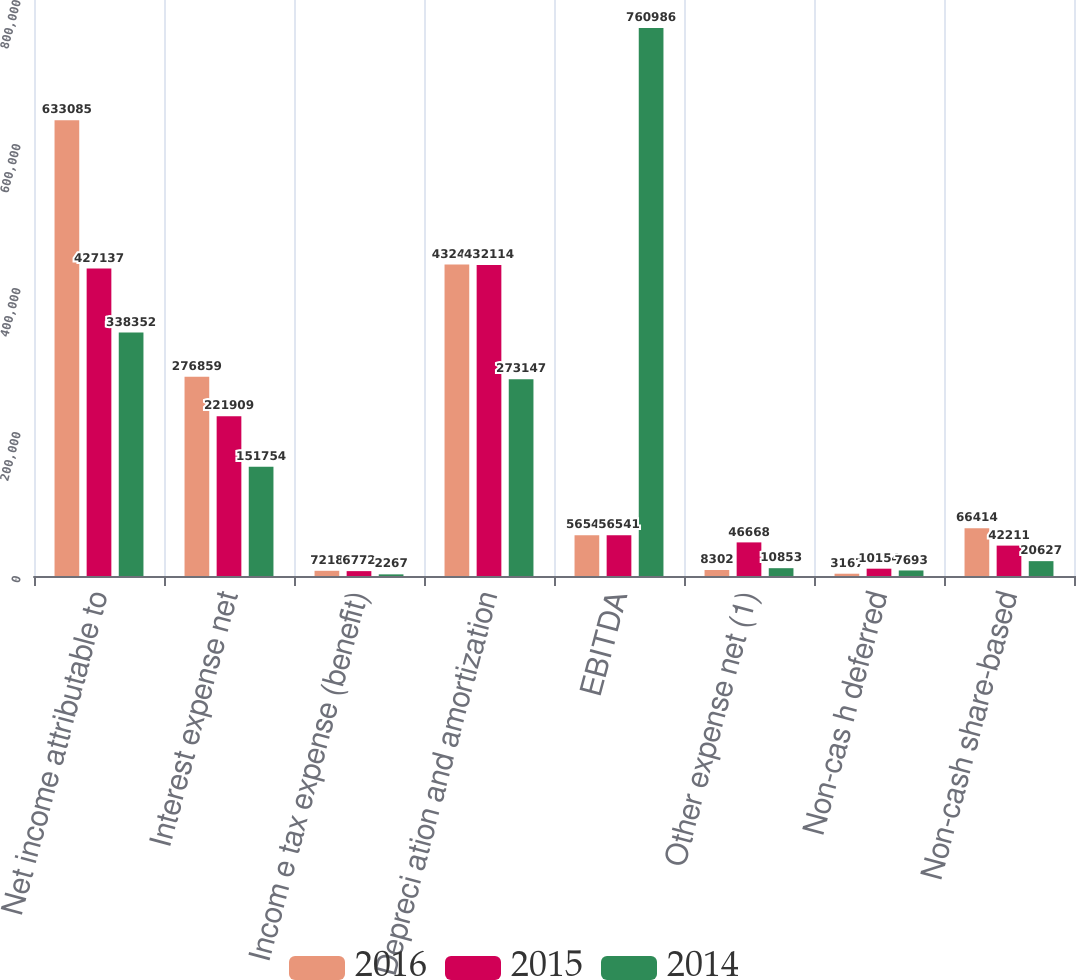Convert chart to OTSL. <chart><loc_0><loc_0><loc_500><loc_500><stacked_bar_chart><ecel><fcel>Net income attributable to<fcel>Interest expense net<fcel>Incom e tax expense (benefit)<fcel>Depreci ation and amortization<fcel>EBITDA<fcel>Other expense net (1)<fcel>Non-cas h deferred<fcel>Non-cash share-based<nl><fcel>2016<fcel>633085<fcel>276859<fcel>7218<fcel>432495<fcel>56541<fcel>8302<fcel>3167<fcel>66414<nl><fcel>2015<fcel>427137<fcel>221909<fcel>6772<fcel>432114<fcel>56541<fcel>46668<fcel>10154<fcel>42211<nl><fcel>2014<fcel>338352<fcel>151754<fcel>2267<fcel>273147<fcel>760986<fcel>10853<fcel>7693<fcel>20627<nl></chart> 